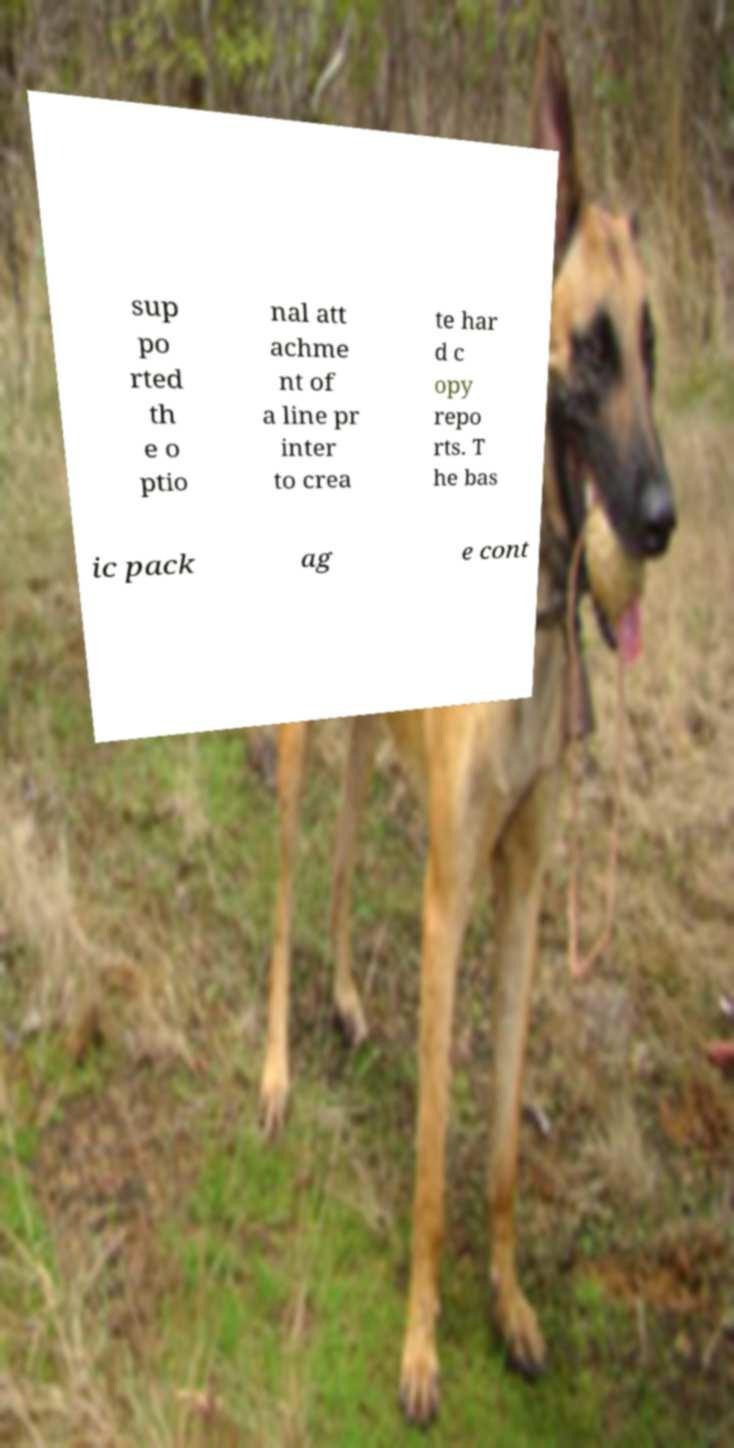Could you extract and type out the text from this image? sup po rted th e o ptio nal att achme nt of a line pr inter to crea te har d c opy repo rts. T he bas ic pack ag e cont 